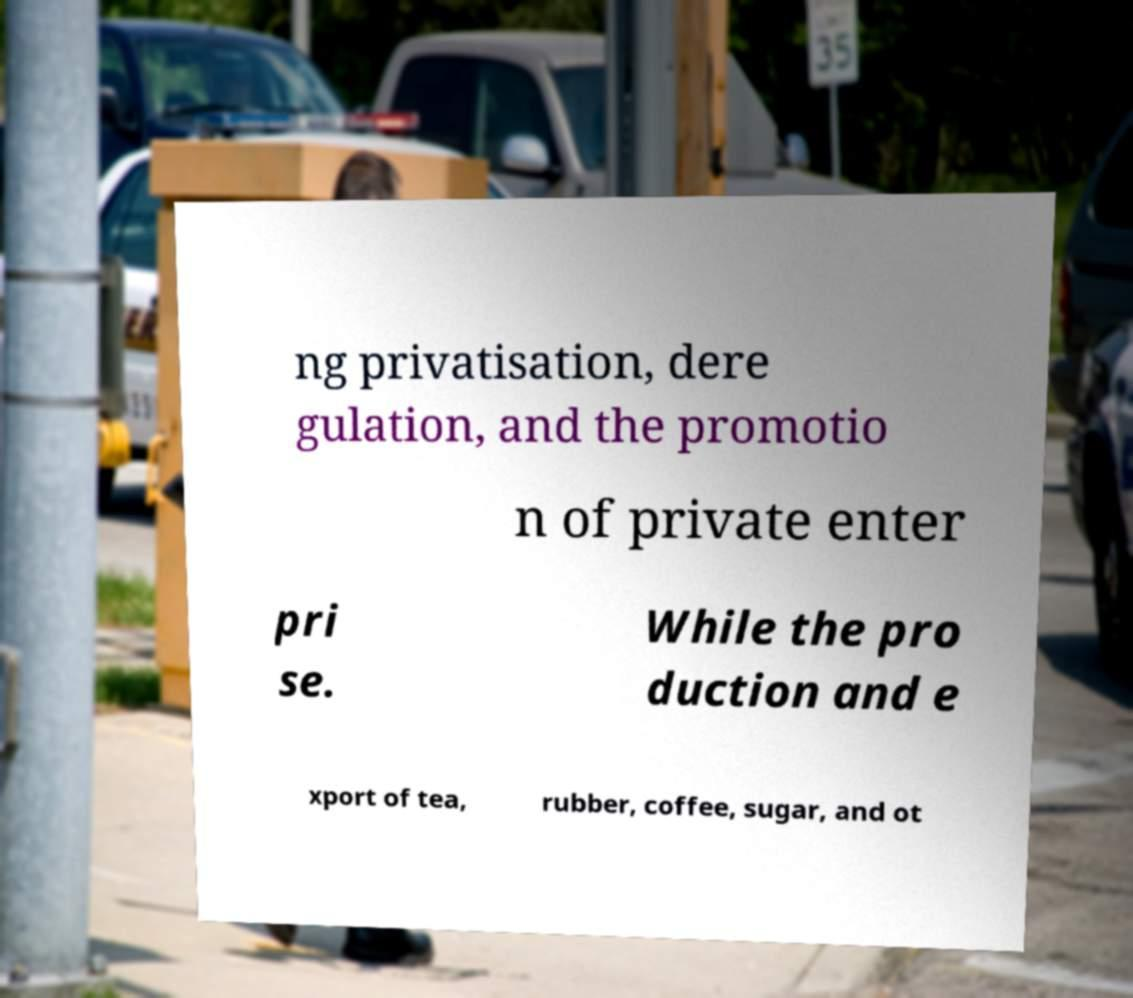For documentation purposes, I need the text within this image transcribed. Could you provide that? ng privatisation, dere gulation, and the promotio n of private enter pri se. While the pro duction and e xport of tea, rubber, coffee, sugar, and ot 